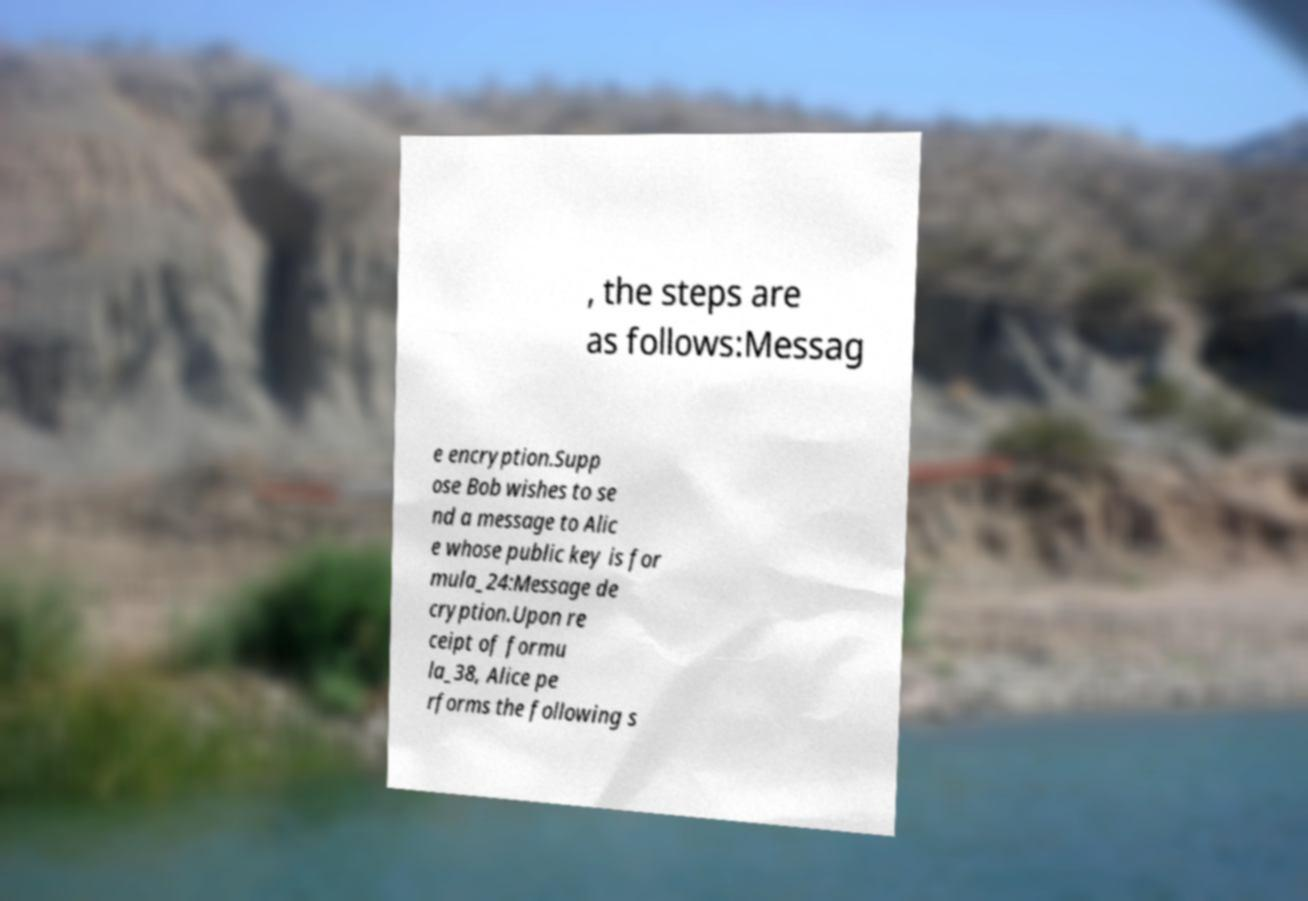Can you read and provide the text displayed in the image?This photo seems to have some interesting text. Can you extract and type it out for me? , the steps are as follows:Messag e encryption.Supp ose Bob wishes to se nd a message to Alic e whose public key is for mula_24:Message de cryption.Upon re ceipt of formu la_38, Alice pe rforms the following s 